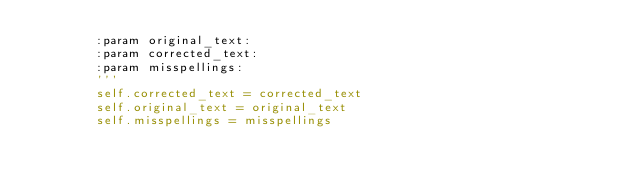Convert code to text. <code><loc_0><loc_0><loc_500><loc_500><_Python_>        :param original_text:
        :param corrected_text:
        :param misspellings:
        '''
        self.corrected_text = corrected_text
        self.original_text = original_text
        self.misspellings = misspellings



</code> 